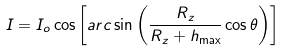<formula> <loc_0><loc_0><loc_500><loc_500>I = I _ { o } \cos \left [ a r c \sin \left ( \frac { R _ { z } } { R _ { z } + h _ { \max } } \cos \theta \right ) \right ]</formula> 